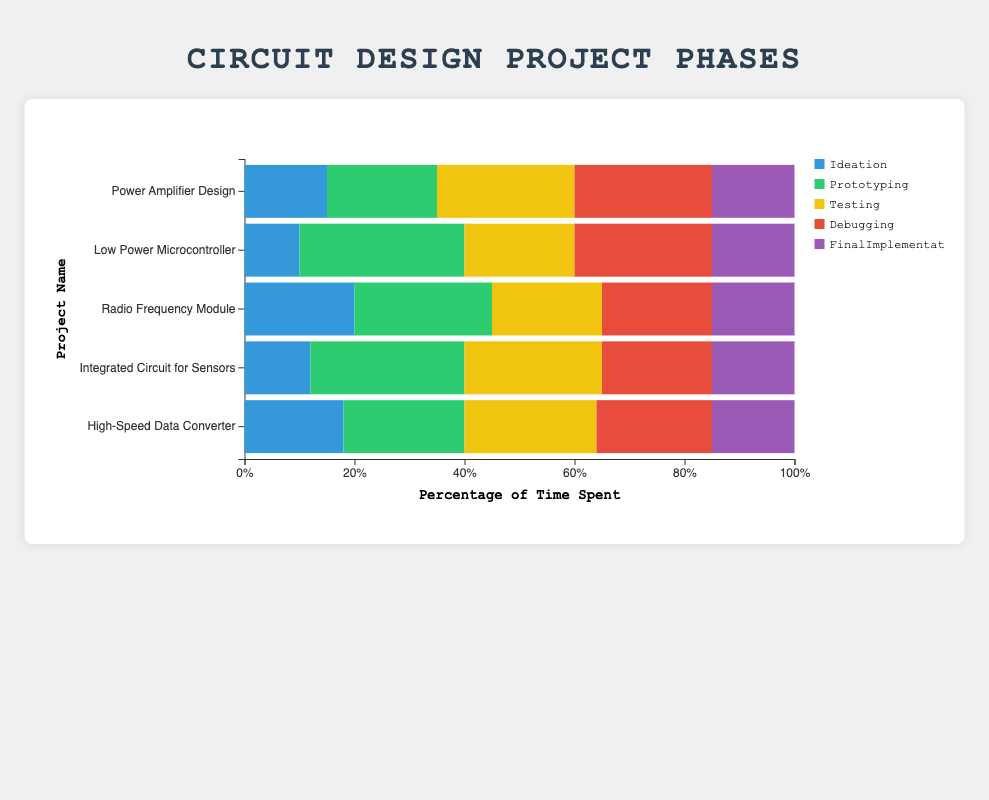What project has the highest percentage of time spent on prototyping? The bar representing the "Low Power Microcontroller" project in the prototyping section is the longest compared to other projects, indicating it has the highest percentage of time spent.
Answer: Low Power Microcontroller What is the total percentage of time spent on all phases for the "Radio Frequency Module" project? Sum the values of Ideation (20), Prototyping (25), Testing (20), Debugging (20), and Final Implementation (15) for the "Radio Frequency Module" project, resulting in 20 + 25 + 20 + 20 + 15 = 100%.
Answer: 100% Which phase has the lowest percentage of time spent on across all projects? The "Final Implementation" phase consistently has shorter bars across all projects, indicating the lowest percentage of time compared to other phases.
Answer: Final Implementation How do the time percentages for debugging compare between "Power Amplifier Design" and "High-Speed Data Converter"? Compare the lengths of the bars representing debugging in both projects: "Power Amplifier Design" has 25%, while "High-Speed Data Converter" has 21%.
Answer: Power Amplifier Design spends more time on debugging than High-Speed Data Converter Calculate the average time spent on testing across all projects. Sum the percentages of time spent on testing for all projects: (25 + 20 + 20 + 25 + 24) = 114. Then, divide by the number of projects (5): 114 / 5 = 22.8%.
Answer: 22.8% Which phase has the most varied time distribution across different projects? By observing the bar lengths for each phase across different projects, the "Prototyping" phase shows the most variation in bar lengths (ranging from 20% to 30%).
Answer: Prototyping What project spends the least amount of time on ideation? Identify the project with the shortest bar in the ideation phase. The "Low Power Microcontroller" project has 10%, which is the least.
Answer: Low Power Microcontroller Compare the total time spent on debugging and final implementation for "Integrated Circuit for Sensors". Sum the time spent on debugging (20%) and final implementation (15%) for "Integrated Circuit for Sensors": 20 + 15 = 35%.
Answer: 35% What is the percentage difference in prototyping time between "Radio Frequency Module" and "Integrated Circuit for Sensors"? Subtract the prototyping percentages of the two projects: 28% (Integrated Circuit for Sensors) - 25% (Radio Frequency Module) = 3%.
Answer: 3% Which project has a more balanced distribution of time across all phases? "High-Speed Data Converter" demonstrates relatively even bar lengths across all phases when compared visually to other projects, indicating a more balanced time distribution.
Answer: High-Speed Data Converter 